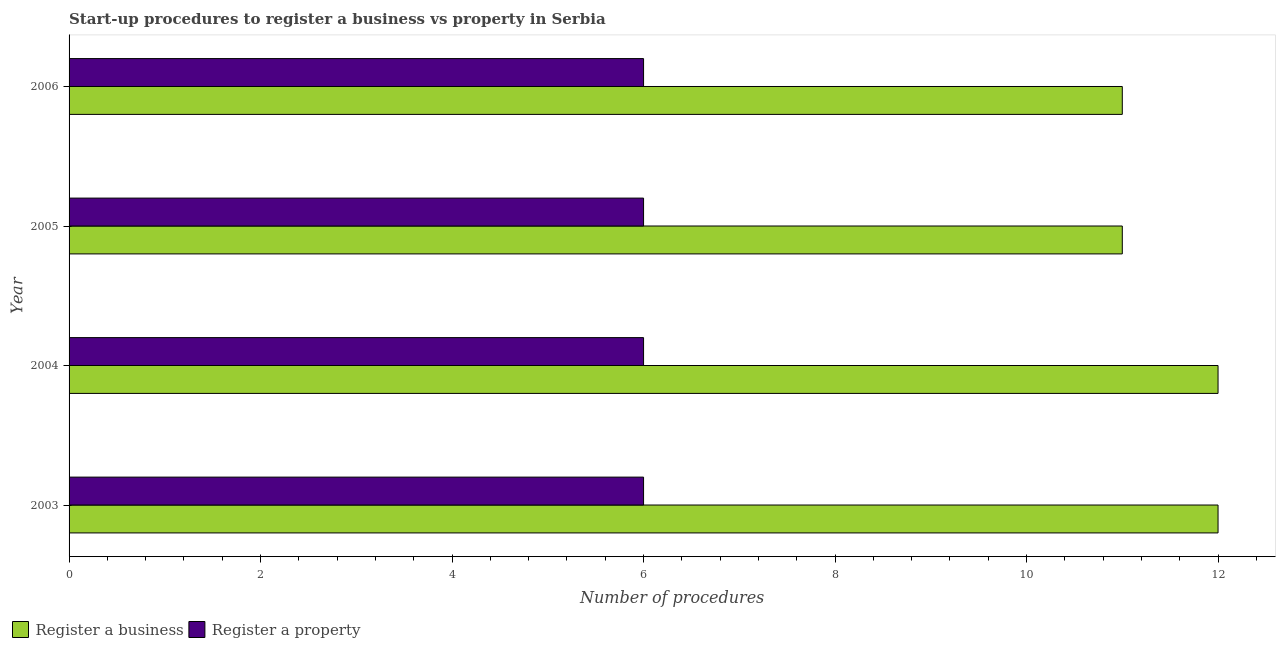How many different coloured bars are there?
Make the answer very short. 2. Are the number of bars per tick equal to the number of legend labels?
Give a very brief answer. Yes. Are the number of bars on each tick of the Y-axis equal?
Give a very brief answer. Yes. How many bars are there on the 3rd tick from the bottom?
Ensure brevity in your answer.  2. What is the label of the 1st group of bars from the top?
Give a very brief answer. 2006. In how many cases, is the number of bars for a given year not equal to the number of legend labels?
Provide a short and direct response. 0. Across all years, what is the maximum number of procedures to register a business?
Your response must be concise. 12. Across all years, what is the minimum number of procedures to register a business?
Keep it short and to the point. 11. In which year was the number of procedures to register a business minimum?
Keep it short and to the point. 2005. What is the total number of procedures to register a business in the graph?
Provide a succinct answer. 46. What is the difference between the number of procedures to register a business in 2003 and that in 2005?
Give a very brief answer. 1. What is the difference between the number of procedures to register a property in 2004 and the number of procedures to register a business in 2003?
Provide a short and direct response. -6. In the year 2003, what is the difference between the number of procedures to register a property and number of procedures to register a business?
Give a very brief answer. -6. In how many years, is the number of procedures to register a business greater than 8.4 ?
Make the answer very short. 4. What is the ratio of the number of procedures to register a property in 2004 to that in 2006?
Ensure brevity in your answer.  1. Is the number of procedures to register a property in 2003 less than that in 2006?
Offer a very short reply. No. What is the difference between the highest and the second highest number of procedures to register a business?
Your response must be concise. 0. What is the difference between the highest and the lowest number of procedures to register a property?
Give a very brief answer. 0. In how many years, is the number of procedures to register a property greater than the average number of procedures to register a property taken over all years?
Ensure brevity in your answer.  0. Is the sum of the number of procedures to register a business in 2005 and 2006 greater than the maximum number of procedures to register a property across all years?
Provide a short and direct response. Yes. What does the 1st bar from the top in 2003 represents?
Offer a terse response. Register a property. What does the 1st bar from the bottom in 2005 represents?
Your answer should be very brief. Register a business. How many bars are there?
Offer a very short reply. 8. How many years are there in the graph?
Keep it short and to the point. 4. What is the difference between two consecutive major ticks on the X-axis?
Your answer should be compact. 2. Does the graph contain grids?
Make the answer very short. No. Where does the legend appear in the graph?
Your response must be concise. Bottom left. How many legend labels are there?
Offer a very short reply. 2. What is the title of the graph?
Keep it short and to the point. Start-up procedures to register a business vs property in Serbia. Does "Under-5(male)" appear as one of the legend labels in the graph?
Your answer should be compact. No. What is the label or title of the X-axis?
Offer a terse response. Number of procedures. What is the label or title of the Y-axis?
Give a very brief answer. Year. What is the Number of procedures in Register a business in 2004?
Your answer should be compact. 12. What is the Number of procedures in Register a property in 2004?
Keep it short and to the point. 6. What is the Number of procedures of Register a property in 2006?
Offer a very short reply. 6. Across all years, what is the maximum Number of procedures of Register a property?
Your answer should be compact. 6. What is the total Number of procedures in Register a property in the graph?
Ensure brevity in your answer.  24. What is the difference between the Number of procedures in Register a business in 2003 and that in 2004?
Your answer should be very brief. 0. What is the difference between the Number of procedures in Register a business in 2003 and that in 2005?
Ensure brevity in your answer.  1. What is the difference between the Number of procedures of Register a property in 2003 and that in 2005?
Provide a short and direct response. 0. What is the difference between the Number of procedures of Register a business in 2003 and that in 2006?
Give a very brief answer. 1. What is the difference between the Number of procedures in Register a property in 2004 and that in 2005?
Provide a succinct answer. 0. What is the difference between the Number of procedures in Register a property in 2004 and that in 2006?
Keep it short and to the point. 0. What is the difference between the Number of procedures in Register a business in 2005 and that in 2006?
Ensure brevity in your answer.  0. What is the difference between the Number of procedures in Register a business in 2003 and the Number of procedures in Register a property in 2006?
Offer a terse response. 6. What is the difference between the Number of procedures of Register a business in 2004 and the Number of procedures of Register a property in 2005?
Make the answer very short. 6. What is the difference between the Number of procedures of Register a business in 2004 and the Number of procedures of Register a property in 2006?
Keep it short and to the point. 6. What is the difference between the Number of procedures of Register a business in 2005 and the Number of procedures of Register a property in 2006?
Ensure brevity in your answer.  5. What is the average Number of procedures in Register a business per year?
Your answer should be very brief. 11.5. In the year 2003, what is the difference between the Number of procedures of Register a business and Number of procedures of Register a property?
Provide a succinct answer. 6. What is the ratio of the Number of procedures in Register a property in 2003 to that in 2004?
Offer a terse response. 1. What is the ratio of the Number of procedures in Register a property in 2003 to that in 2005?
Your answer should be very brief. 1. What is the ratio of the Number of procedures of Register a business in 2003 to that in 2006?
Make the answer very short. 1.09. What is the ratio of the Number of procedures of Register a property in 2003 to that in 2006?
Your answer should be compact. 1. What is the ratio of the Number of procedures in Register a business in 2004 to that in 2005?
Your response must be concise. 1.09. What is the ratio of the Number of procedures of Register a property in 2004 to that in 2005?
Provide a short and direct response. 1. What is the ratio of the Number of procedures in Register a business in 2004 to that in 2006?
Offer a very short reply. 1.09. What is the ratio of the Number of procedures of Register a business in 2005 to that in 2006?
Your answer should be compact. 1. What is the difference between the highest and the second highest Number of procedures of Register a business?
Ensure brevity in your answer.  0. What is the difference between the highest and the second highest Number of procedures in Register a property?
Keep it short and to the point. 0. What is the difference between the highest and the lowest Number of procedures in Register a business?
Give a very brief answer. 1. What is the difference between the highest and the lowest Number of procedures of Register a property?
Provide a short and direct response. 0. 